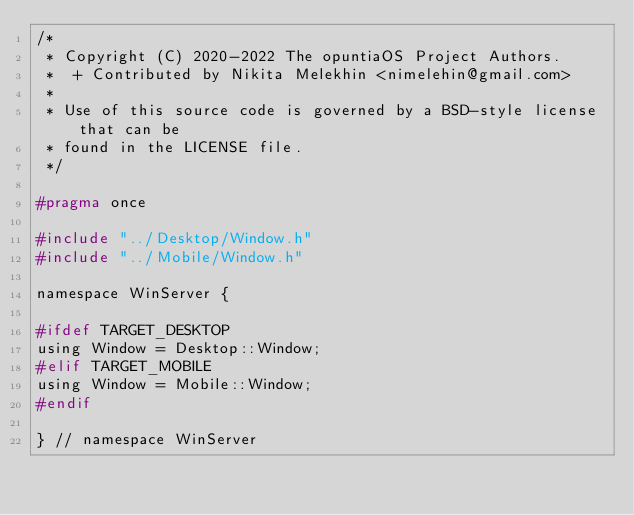<code> <loc_0><loc_0><loc_500><loc_500><_C_>/*
 * Copyright (C) 2020-2022 The opuntiaOS Project Authors.
 *  + Contributed by Nikita Melekhin <nimelehin@gmail.com>
 *
 * Use of this source code is governed by a BSD-style license that can be
 * found in the LICENSE file.
 */

#pragma once

#include "../Desktop/Window.h"
#include "../Mobile/Window.h"

namespace WinServer {

#ifdef TARGET_DESKTOP
using Window = Desktop::Window;
#elif TARGET_MOBILE
using Window = Mobile::Window;
#endif

} // namespace WinServer</code> 